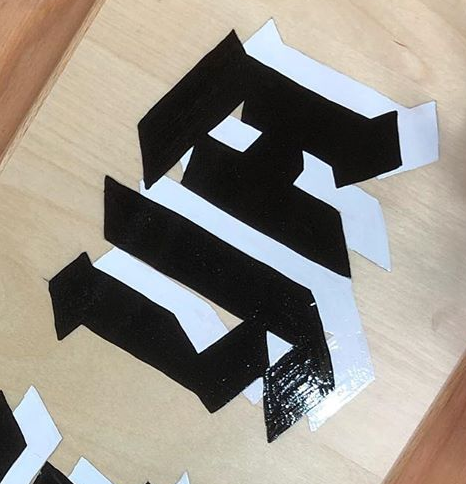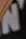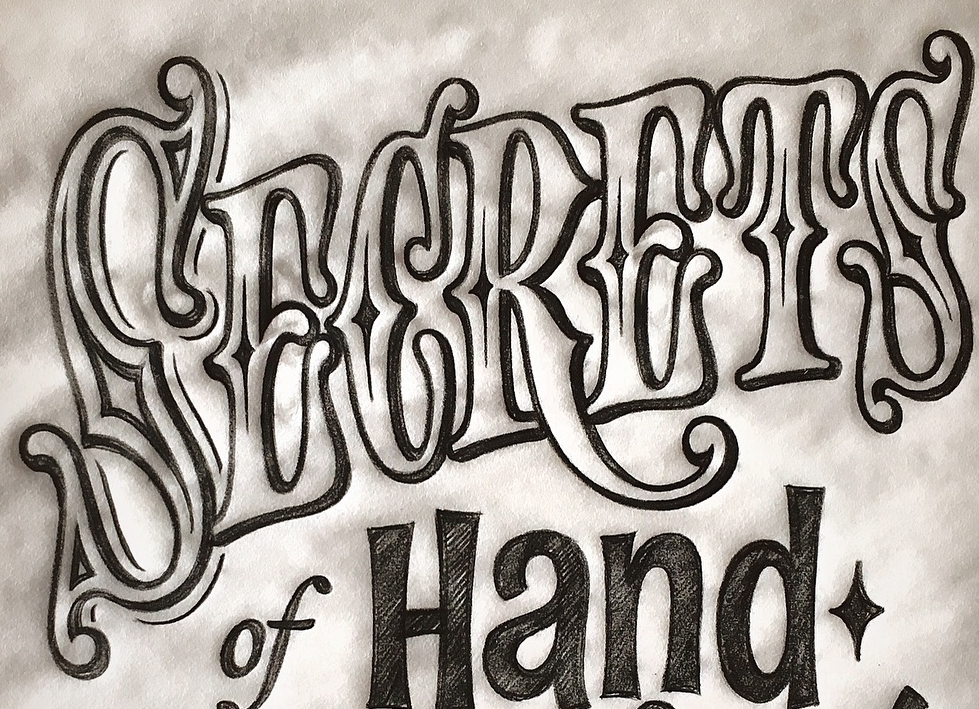What text is displayed in these images sequentially, separated by a semicolon? YA; N; SECRETS 